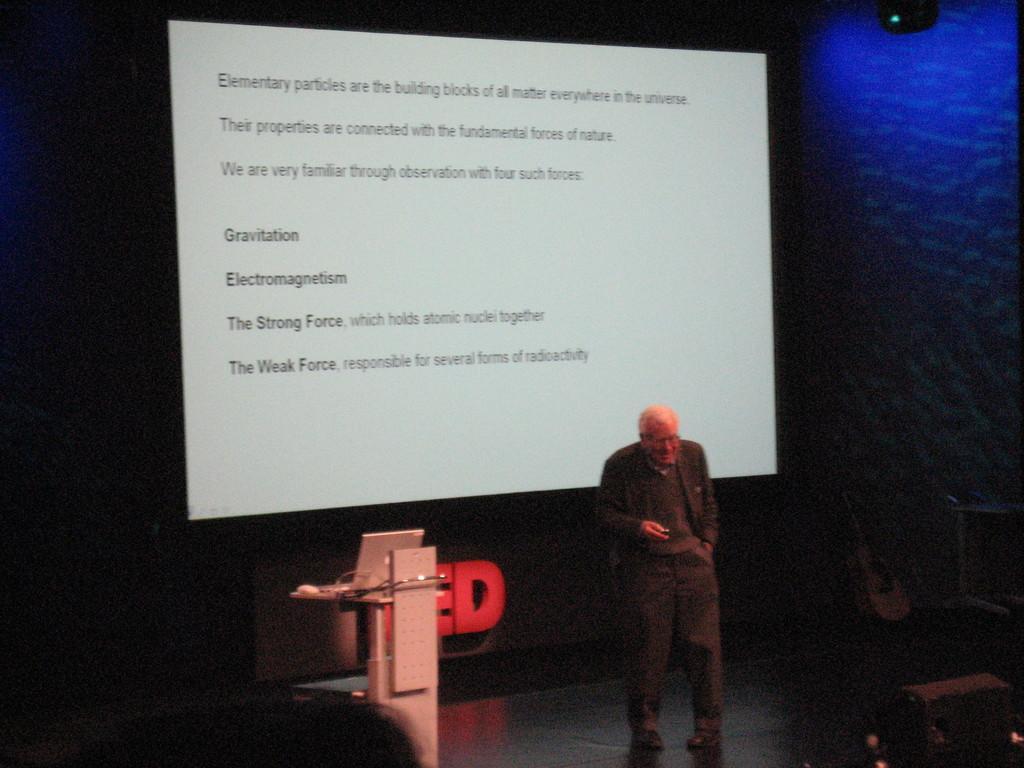How would you summarize this image in a sentence or two? In this picture we can see a man standing on the floor, screen, podium, laptop, some objects and in the background it is dark. 